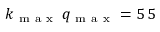<formula> <loc_0><loc_0><loc_500><loc_500>k _ { m a x } \, q _ { m a x } = 5 \, 5</formula> 